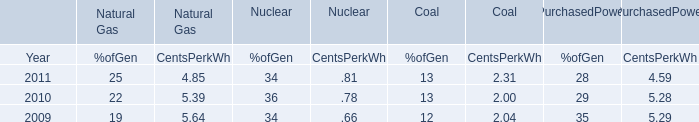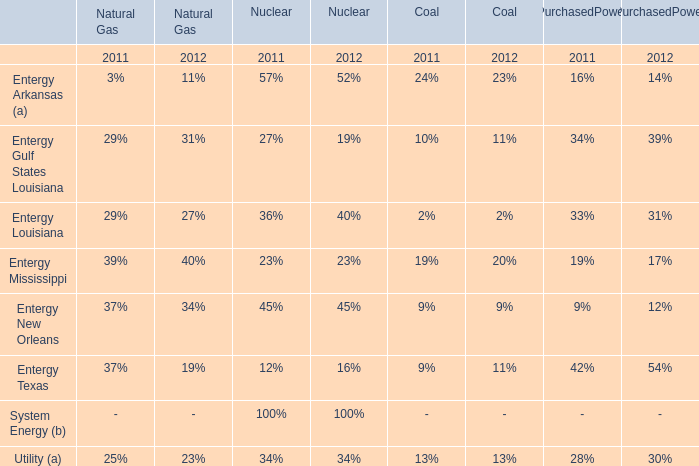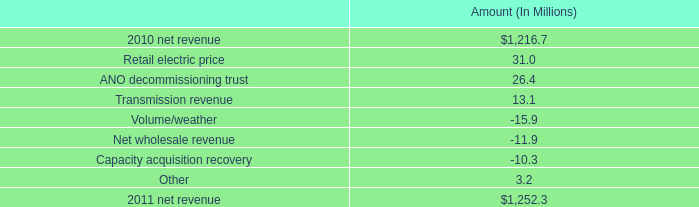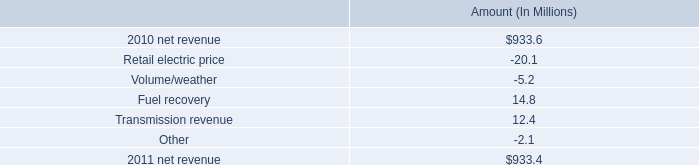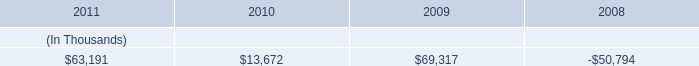from the increase in net revenue , what percentage is attributed to the change in retail electric price? 
Computations: (31.0 / (1252.3 - 1216.7))
Answer: 0.87079. 